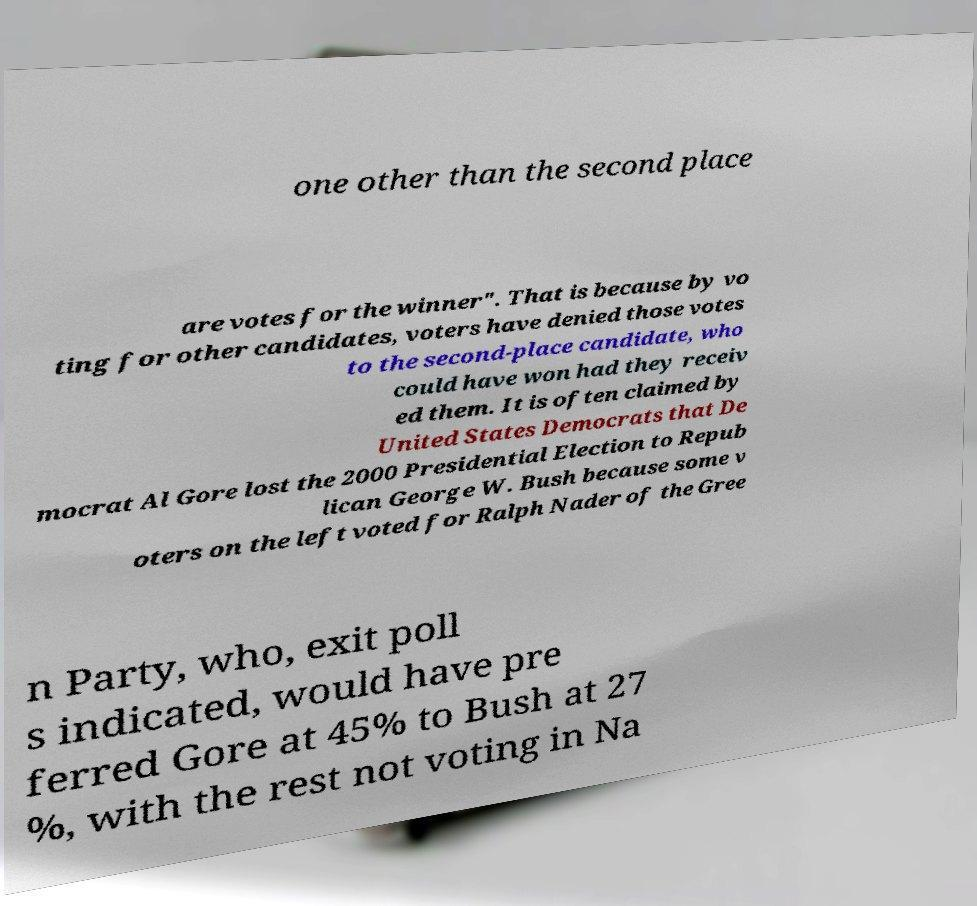There's text embedded in this image that I need extracted. Can you transcribe it verbatim? one other than the second place are votes for the winner". That is because by vo ting for other candidates, voters have denied those votes to the second-place candidate, who could have won had they receiv ed them. It is often claimed by United States Democrats that De mocrat Al Gore lost the 2000 Presidential Election to Repub lican George W. Bush because some v oters on the left voted for Ralph Nader of the Gree n Party, who, exit poll s indicated, would have pre ferred Gore at 45% to Bush at 27 %, with the rest not voting in Na 